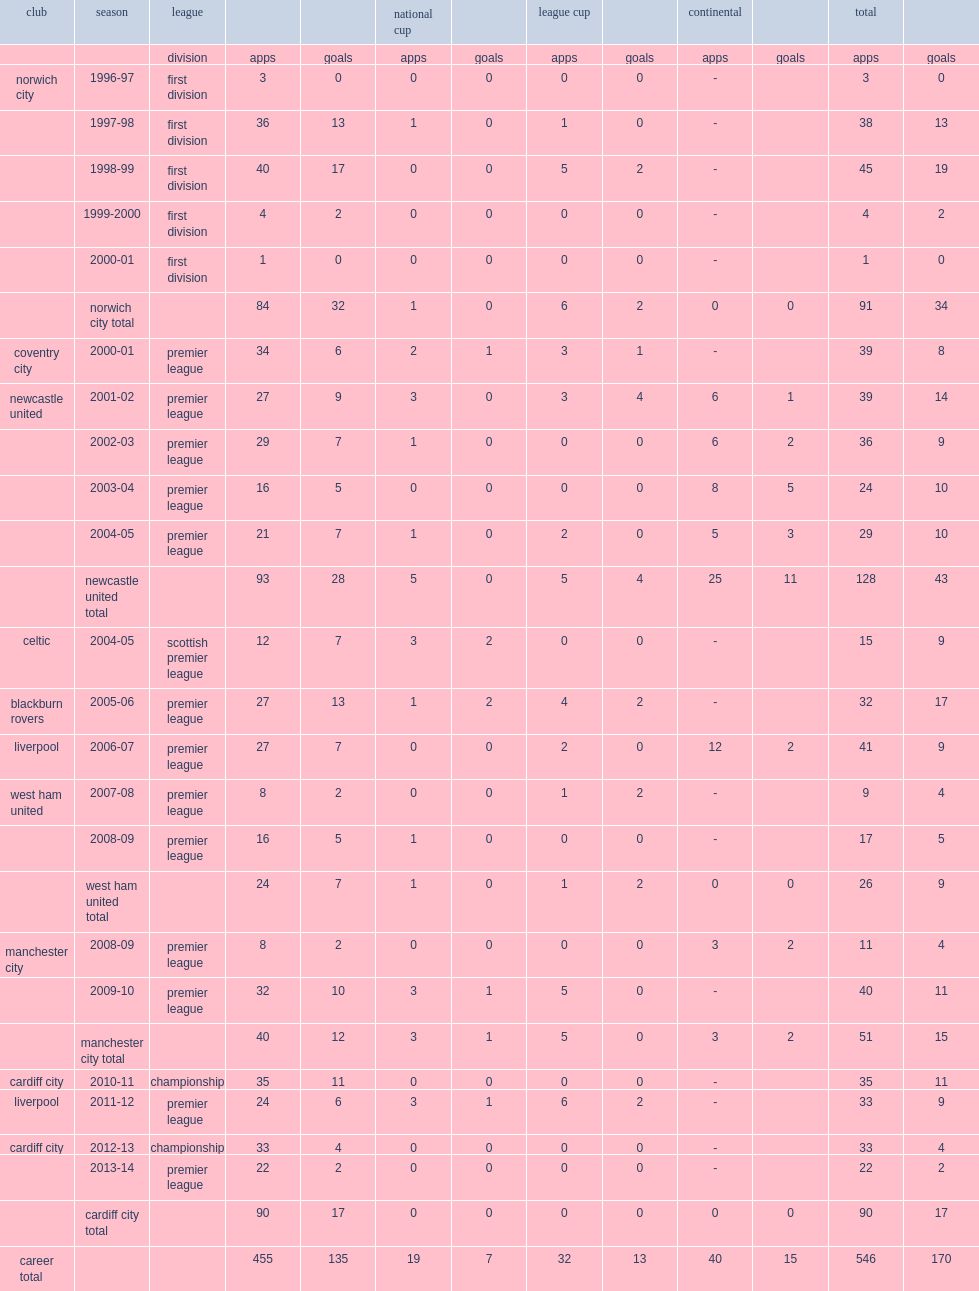What was the total number of appearances made by bellamy for newcastle? 128.0. 